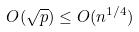<formula> <loc_0><loc_0><loc_500><loc_500>O ( \sqrt { p } ) \leq O ( n ^ { 1 / 4 } )</formula> 